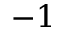Convert formula to latex. <formula><loc_0><loc_0><loc_500><loc_500>- 1</formula> 